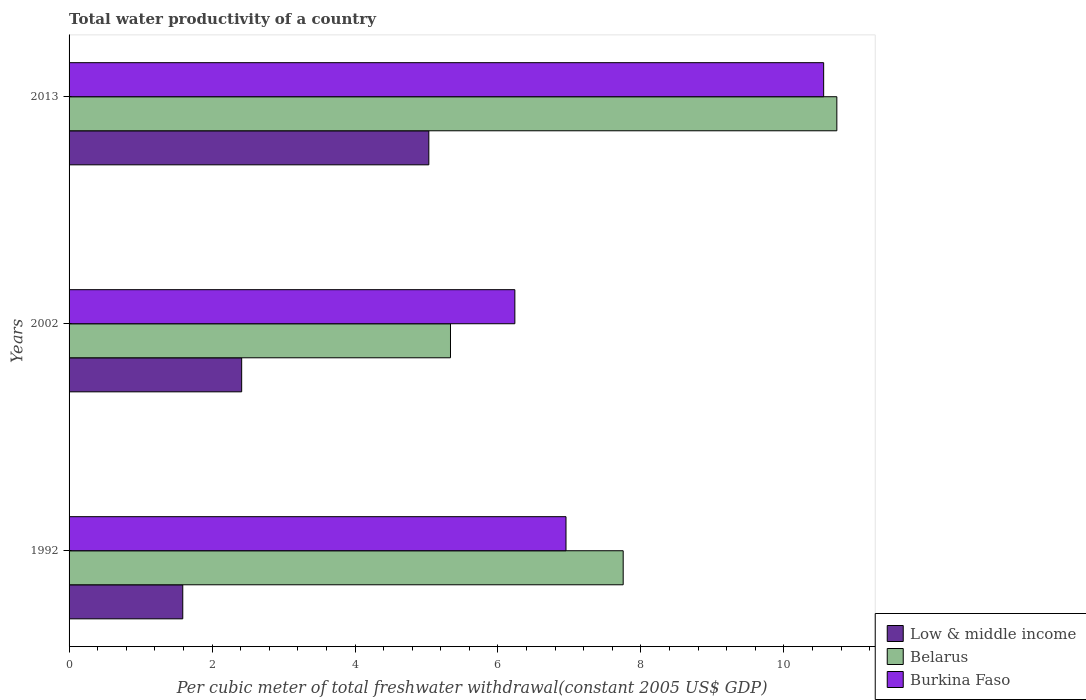How many different coloured bars are there?
Your answer should be very brief. 3. How many groups of bars are there?
Ensure brevity in your answer.  3. Are the number of bars per tick equal to the number of legend labels?
Your answer should be compact. Yes. Are the number of bars on each tick of the Y-axis equal?
Provide a succinct answer. Yes. How many bars are there on the 2nd tick from the bottom?
Your response must be concise. 3. What is the label of the 3rd group of bars from the top?
Offer a terse response. 1992. What is the total water productivity in Belarus in 2013?
Ensure brevity in your answer.  10.74. Across all years, what is the maximum total water productivity in Low & middle income?
Your answer should be very brief. 5.03. Across all years, what is the minimum total water productivity in Belarus?
Offer a very short reply. 5.34. In which year was the total water productivity in Low & middle income minimum?
Your response must be concise. 1992. What is the total total water productivity in Belarus in the graph?
Make the answer very short. 23.83. What is the difference between the total water productivity in Low & middle income in 1992 and that in 2013?
Provide a short and direct response. -3.44. What is the difference between the total water productivity in Belarus in 1992 and the total water productivity in Burkina Faso in 2002?
Give a very brief answer. 1.52. What is the average total water productivity in Burkina Faso per year?
Your response must be concise. 7.91. In the year 2002, what is the difference between the total water productivity in Belarus and total water productivity in Burkina Faso?
Offer a terse response. -0.9. In how many years, is the total water productivity in Burkina Faso greater than 2.4 US$?
Your response must be concise. 3. What is the ratio of the total water productivity in Burkina Faso in 1992 to that in 2013?
Keep it short and to the point. 0.66. Is the total water productivity in Burkina Faso in 1992 less than that in 2002?
Your answer should be very brief. No. Is the difference between the total water productivity in Belarus in 2002 and 2013 greater than the difference between the total water productivity in Burkina Faso in 2002 and 2013?
Provide a short and direct response. No. What is the difference between the highest and the second highest total water productivity in Burkina Faso?
Your response must be concise. 3.6. What is the difference between the highest and the lowest total water productivity in Burkina Faso?
Provide a short and direct response. 4.32. In how many years, is the total water productivity in Low & middle income greater than the average total water productivity in Low & middle income taken over all years?
Ensure brevity in your answer.  1. What does the 1st bar from the top in 2013 represents?
Your answer should be compact. Burkina Faso. What does the 2nd bar from the bottom in 2002 represents?
Your answer should be very brief. Belarus. How many bars are there?
Give a very brief answer. 9. Are all the bars in the graph horizontal?
Give a very brief answer. Yes. How many years are there in the graph?
Offer a terse response. 3. Are the values on the major ticks of X-axis written in scientific E-notation?
Provide a short and direct response. No. Does the graph contain any zero values?
Provide a succinct answer. No. Where does the legend appear in the graph?
Your answer should be very brief. Bottom right. What is the title of the graph?
Keep it short and to the point. Total water productivity of a country. Does "Mauritius" appear as one of the legend labels in the graph?
Your response must be concise. No. What is the label or title of the X-axis?
Offer a very short reply. Per cubic meter of total freshwater withdrawal(constant 2005 US$ GDP). What is the Per cubic meter of total freshwater withdrawal(constant 2005 US$ GDP) of Low & middle income in 1992?
Keep it short and to the point. 1.59. What is the Per cubic meter of total freshwater withdrawal(constant 2005 US$ GDP) of Belarus in 1992?
Keep it short and to the point. 7.75. What is the Per cubic meter of total freshwater withdrawal(constant 2005 US$ GDP) of Burkina Faso in 1992?
Give a very brief answer. 6.95. What is the Per cubic meter of total freshwater withdrawal(constant 2005 US$ GDP) of Low & middle income in 2002?
Provide a short and direct response. 2.41. What is the Per cubic meter of total freshwater withdrawal(constant 2005 US$ GDP) of Belarus in 2002?
Offer a terse response. 5.34. What is the Per cubic meter of total freshwater withdrawal(constant 2005 US$ GDP) of Burkina Faso in 2002?
Offer a terse response. 6.24. What is the Per cubic meter of total freshwater withdrawal(constant 2005 US$ GDP) of Low & middle income in 2013?
Give a very brief answer. 5.03. What is the Per cubic meter of total freshwater withdrawal(constant 2005 US$ GDP) in Belarus in 2013?
Provide a succinct answer. 10.74. What is the Per cubic meter of total freshwater withdrawal(constant 2005 US$ GDP) in Burkina Faso in 2013?
Offer a terse response. 10.56. Across all years, what is the maximum Per cubic meter of total freshwater withdrawal(constant 2005 US$ GDP) of Low & middle income?
Keep it short and to the point. 5.03. Across all years, what is the maximum Per cubic meter of total freshwater withdrawal(constant 2005 US$ GDP) in Belarus?
Ensure brevity in your answer.  10.74. Across all years, what is the maximum Per cubic meter of total freshwater withdrawal(constant 2005 US$ GDP) in Burkina Faso?
Provide a succinct answer. 10.56. Across all years, what is the minimum Per cubic meter of total freshwater withdrawal(constant 2005 US$ GDP) of Low & middle income?
Keep it short and to the point. 1.59. Across all years, what is the minimum Per cubic meter of total freshwater withdrawal(constant 2005 US$ GDP) of Belarus?
Your response must be concise. 5.34. Across all years, what is the minimum Per cubic meter of total freshwater withdrawal(constant 2005 US$ GDP) in Burkina Faso?
Your response must be concise. 6.24. What is the total Per cubic meter of total freshwater withdrawal(constant 2005 US$ GDP) of Low & middle income in the graph?
Provide a succinct answer. 9.04. What is the total Per cubic meter of total freshwater withdrawal(constant 2005 US$ GDP) of Belarus in the graph?
Keep it short and to the point. 23.83. What is the total Per cubic meter of total freshwater withdrawal(constant 2005 US$ GDP) in Burkina Faso in the graph?
Provide a succinct answer. 23.75. What is the difference between the Per cubic meter of total freshwater withdrawal(constant 2005 US$ GDP) in Low & middle income in 1992 and that in 2002?
Provide a short and direct response. -0.82. What is the difference between the Per cubic meter of total freshwater withdrawal(constant 2005 US$ GDP) in Belarus in 1992 and that in 2002?
Your response must be concise. 2.42. What is the difference between the Per cubic meter of total freshwater withdrawal(constant 2005 US$ GDP) of Burkina Faso in 1992 and that in 2002?
Provide a succinct answer. 0.72. What is the difference between the Per cubic meter of total freshwater withdrawal(constant 2005 US$ GDP) in Low & middle income in 1992 and that in 2013?
Keep it short and to the point. -3.44. What is the difference between the Per cubic meter of total freshwater withdrawal(constant 2005 US$ GDP) of Belarus in 1992 and that in 2013?
Keep it short and to the point. -2.99. What is the difference between the Per cubic meter of total freshwater withdrawal(constant 2005 US$ GDP) of Burkina Faso in 1992 and that in 2013?
Offer a terse response. -3.6. What is the difference between the Per cubic meter of total freshwater withdrawal(constant 2005 US$ GDP) in Low & middle income in 2002 and that in 2013?
Give a very brief answer. -2.62. What is the difference between the Per cubic meter of total freshwater withdrawal(constant 2005 US$ GDP) of Belarus in 2002 and that in 2013?
Provide a succinct answer. -5.41. What is the difference between the Per cubic meter of total freshwater withdrawal(constant 2005 US$ GDP) of Burkina Faso in 2002 and that in 2013?
Make the answer very short. -4.32. What is the difference between the Per cubic meter of total freshwater withdrawal(constant 2005 US$ GDP) in Low & middle income in 1992 and the Per cubic meter of total freshwater withdrawal(constant 2005 US$ GDP) in Belarus in 2002?
Offer a terse response. -3.75. What is the difference between the Per cubic meter of total freshwater withdrawal(constant 2005 US$ GDP) of Low & middle income in 1992 and the Per cubic meter of total freshwater withdrawal(constant 2005 US$ GDP) of Burkina Faso in 2002?
Your answer should be compact. -4.65. What is the difference between the Per cubic meter of total freshwater withdrawal(constant 2005 US$ GDP) in Belarus in 1992 and the Per cubic meter of total freshwater withdrawal(constant 2005 US$ GDP) in Burkina Faso in 2002?
Your answer should be very brief. 1.52. What is the difference between the Per cubic meter of total freshwater withdrawal(constant 2005 US$ GDP) of Low & middle income in 1992 and the Per cubic meter of total freshwater withdrawal(constant 2005 US$ GDP) of Belarus in 2013?
Provide a succinct answer. -9.15. What is the difference between the Per cubic meter of total freshwater withdrawal(constant 2005 US$ GDP) in Low & middle income in 1992 and the Per cubic meter of total freshwater withdrawal(constant 2005 US$ GDP) in Burkina Faso in 2013?
Ensure brevity in your answer.  -8.97. What is the difference between the Per cubic meter of total freshwater withdrawal(constant 2005 US$ GDP) of Belarus in 1992 and the Per cubic meter of total freshwater withdrawal(constant 2005 US$ GDP) of Burkina Faso in 2013?
Your response must be concise. -2.8. What is the difference between the Per cubic meter of total freshwater withdrawal(constant 2005 US$ GDP) of Low & middle income in 2002 and the Per cubic meter of total freshwater withdrawal(constant 2005 US$ GDP) of Belarus in 2013?
Provide a short and direct response. -8.33. What is the difference between the Per cubic meter of total freshwater withdrawal(constant 2005 US$ GDP) of Low & middle income in 2002 and the Per cubic meter of total freshwater withdrawal(constant 2005 US$ GDP) of Burkina Faso in 2013?
Provide a succinct answer. -8.14. What is the difference between the Per cubic meter of total freshwater withdrawal(constant 2005 US$ GDP) in Belarus in 2002 and the Per cubic meter of total freshwater withdrawal(constant 2005 US$ GDP) in Burkina Faso in 2013?
Give a very brief answer. -5.22. What is the average Per cubic meter of total freshwater withdrawal(constant 2005 US$ GDP) of Low & middle income per year?
Your answer should be compact. 3.01. What is the average Per cubic meter of total freshwater withdrawal(constant 2005 US$ GDP) in Belarus per year?
Keep it short and to the point. 7.94. What is the average Per cubic meter of total freshwater withdrawal(constant 2005 US$ GDP) of Burkina Faso per year?
Give a very brief answer. 7.92. In the year 1992, what is the difference between the Per cubic meter of total freshwater withdrawal(constant 2005 US$ GDP) of Low & middle income and Per cubic meter of total freshwater withdrawal(constant 2005 US$ GDP) of Belarus?
Your answer should be compact. -6.16. In the year 1992, what is the difference between the Per cubic meter of total freshwater withdrawal(constant 2005 US$ GDP) in Low & middle income and Per cubic meter of total freshwater withdrawal(constant 2005 US$ GDP) in Burkina Faso?
Your answer should be compact. -5.36. In the year 1992, what is the difference between the Per cubic meter of total freshwater withdrawal(constant 2005 US$ GDP) of Belarus and Per cubic meter of total freshwater withdrawal(constant 2005 US$ GDP) of Burkina Faso?
Offer a very short reply. 0.8. In the year 2002, what is the difference between the Per cubic meter of total freshwater withdrawal(constant 2005 US$ GDP) of Low & middle income and Per cubic meter of total freshwater withdrawal(constant 2005 US$ GDP) of Belarus?
Offer a very short reply. -2.92. In the year 2002, what is the difference between the Per cubic meter of total freshwater withdrawal(constant 2005 US$ GDP) in Low & middle income and Per cubic meter of total freshwater withdrawal(constant 2005 US$ GDP) in Burkina Faso?
Your answer should be compact. -3.82. In the year 2002, what is the difference between the Per cubic meter of total freshwater withdrawal(constant 2005 US$ GDP) of Belarus and Per cubic meter of total freshwater withdrawal(constant 2005 US$ GDP) of Burkina Faso?
Keep it short and to the point. -0.9. In the year 2013, what is the difference between the Per cubic meter of total freshwater withdrawal(constant 2005 US$ GDP) in Low & middle income and Per cubic meter of total freshwater withdrawal(constant 2005 US$ GDP) in Belarus?
Ensure brevity in your answer.  -5.71. In the year 2013, what is the difference between the Per cubic meter of total freshwater withdrawal(constant 2005 US$ GDP) in Low & middle income and Per cubic meter of total freshwater withdrawal(constant 2005 US$ GDP) in Burkina Faso?
Offer a terse response. -5.52. In the year 2013, what is the difference between the Per cubic meter of total freshwater withdrawal(constant 2005 US$ GDP) in Belarus and Per cubic meter of total freshwater withdrawal(constant 2005 US$ GDP) in Burkina Faso?
Offer a terse response. 0.18. What is the ratio of the Per cubic meter of total freshwater withdrawal(constant 2005 US$ GDP) of Low & middle income in 1992 to that in 2002?
Your response must be concise. 0.66. What is the ratio of the Per cubic meter of total freshwater withdrawal(constant 2005 US$ GDP) in Belarus in 1992 to that in 2002?
Give a very brief answer. 1.45. What is the ratio of the Per cubic meter of total freshwater withdrawal(constant 2005 US$ GDP) of Burkina Faso in 1992 to that in 2002?
Give a very brief answer. 1.11. What is the ratio of the Per cubic meter of total freshwater withdrawal(constant 2005 US$ GDP) in Low & middle income in 1992 to that in 2013?
Your response must be concise. 0.32. What is the ratio of the Per cubic meter of total freshwater withdrawal(constant 2005 US$ GDP) of Belarus in 1992 to that in 2013?
Your answer should be compact. 0.72. What is the ratio of the Per cubic meter of total freshwater withdrawal(constant 2005 US$ GDP) of Burkina Faso in 1992 to that in 2013?
Ensure brevity in your answer.  0.66. What is the ratio of the Per cubic meter of total freshwater withdrawal(constant 2005 US$ GDP) in Low & middle income in 2002 to that in 2013?
Provide a short and direct response. 0.48. What is the ratio of the Per cubic meter of total freshwater withdrawal(constant 2005 US$ GDP) in Belarus in 2002 to that in 2013?
Your response must be concise. 0.5. What is the ratio of the Per cubic meter of total freshwater withdrawal(constant 2005 US$ GDP) of Burkina Faso in 2002 to that in 2013?
Provide a short and direct response. 0.59. What is the difference between the highest and the second highest Per cubic meter of total freshwater withdrawal(constant 2005 US$ GDP) of Low & middle income?
Ensure brevity in your answer.  2.62. What is the difference between the highest and the second highest Per cubic meter of total freshwater withdrawal(constant 2005 US$ GDP) in Belarus?
Ensure brevity in your answer.  2.99. What is the difference between the highest and the second highest Per cubic meter of total freshwater withdrawal(constant 2005 US$ GDP) in Burkina Faso?
Make the answer very short. 3.6. What is the difference between the highest and the lowest Per cubic meter of total freshwater withdrawal(constant 2005 US$ GDP) of Low & middle income?
Your response must be concise. 3.44. What is the difference between the highest and the lowest Per cubic meter of total freshwater withdrawal(constant 2005 US$ GDP) in Belarus?
Make the answer very short. 5.41. What is the difference between the highest and the lowest Per cubic meter of total freshwater withdrawal(constant 2005 US$ GDP) in Burkina Faso?
Offer a terse response. 4.32. 